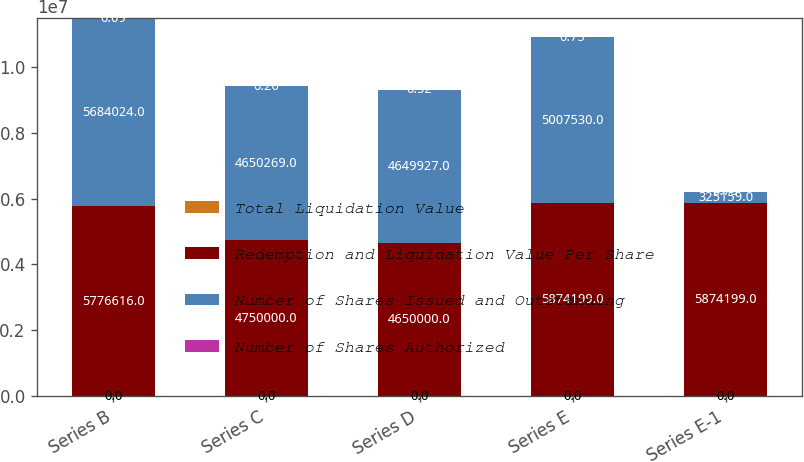Convert chart to OTSL. <chart><loc_0><loc_0><loc_500><loc_500><stacked_bar_chart><ecel><fcel>Series B<fcel>Series C<fcel>Series D<fcel>Series E<fcel>Series E-1<nl><fcel>Total Liquidation Value<fcel>0<fcel>0<fcel>0<fcel>0<fcel>0<nl><fcel>Redemption and Liquidation Value Per Share<fcel>5.77662e+06<fcel>4.75e+06<fcel>4.65e+06<fcel>5.8742e+06<fcel>5.8742e+06<nl><fcel>Number of Shares Issued and Outstanding<fcel>5.68402e+06<fcel>4.65027e+06<fcel>4.64993e+06<fcel>5.00753e+06<fcel>325159<nl><fcel>Number of Shares Authorized<fcel>0.09<fcel>0.26<fcel>0.52<fcel>0.75<fcel>0.75<nl></chart> 